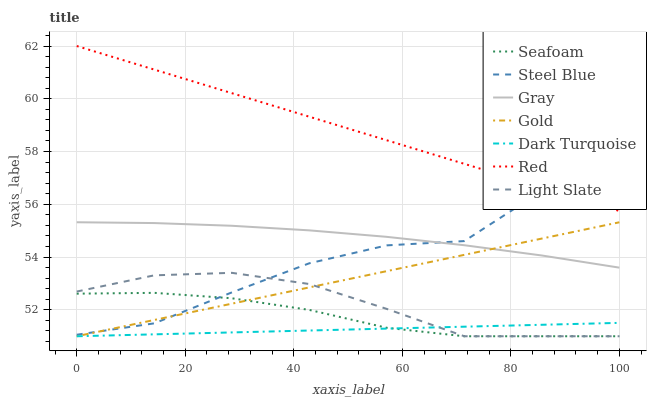Does Dark Turquoise have the minimum area under the curve?
Answer yes or no. Yes. Does Red have the maximum area under the curve?
Answer yes or no. Yes. Does Gold have the minimum area under the curve?
Answer yes or no. No. Does Gold have the maximum area under the curve?
Answer yes or no. No. Is Dark Turquoise the smoothest?
Answer yes or no. Yes. Is Steel Blue the roughest?
Answer yes or no. Yes. Is Gold the smoothest?
Answer yes or no. No. Is Gold the roughest?
Answer yes or no. No. Does Gold have the lowest value?
Answer yes or no. Yes. Does Steel Blue have the lowest value?
Answer yes or no. No. Does Red have the highest value?
Answer yes or no. Yes. Does Gold have the highest value?
Answer yes or no. No. Is Seafoam less than Red?
Answer yes or no. Yes. Is Steel Blue greater than Dark Turquoise?
Answer yes or no. Yes. Does Light Slate intersect Seafoam?
Answer yes or no. Yes. Is Light Slate less than Seafoam?
Answer yes or no. No. Is Light Slate greater than Seafoam?
Answer yes or no. No. Does Seafoam intersect Red?
Answer yes or no. No. 